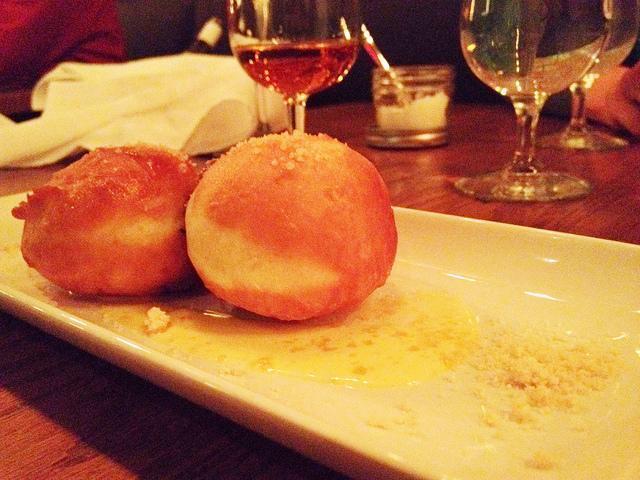How many glasses do you see?
Give a very brief answer. 3. How many wine glasses are there?
Give a very brief answer. 3. How many people are there?
Give a very brief answer. 2. How many dining tables are in the photo?
Give a very brief answer. 1. How many donuts are there?
Give a very brief answer. 2. How many miniature horses are there in the field?
Give a very brief answer. 0. 